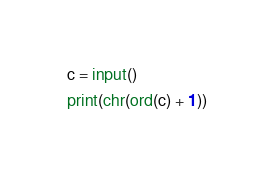<code> <loc_0><loc_0><loc_500><loc_500><_Python_>c = input()

print(chr(ord(c) + 1))</code> 